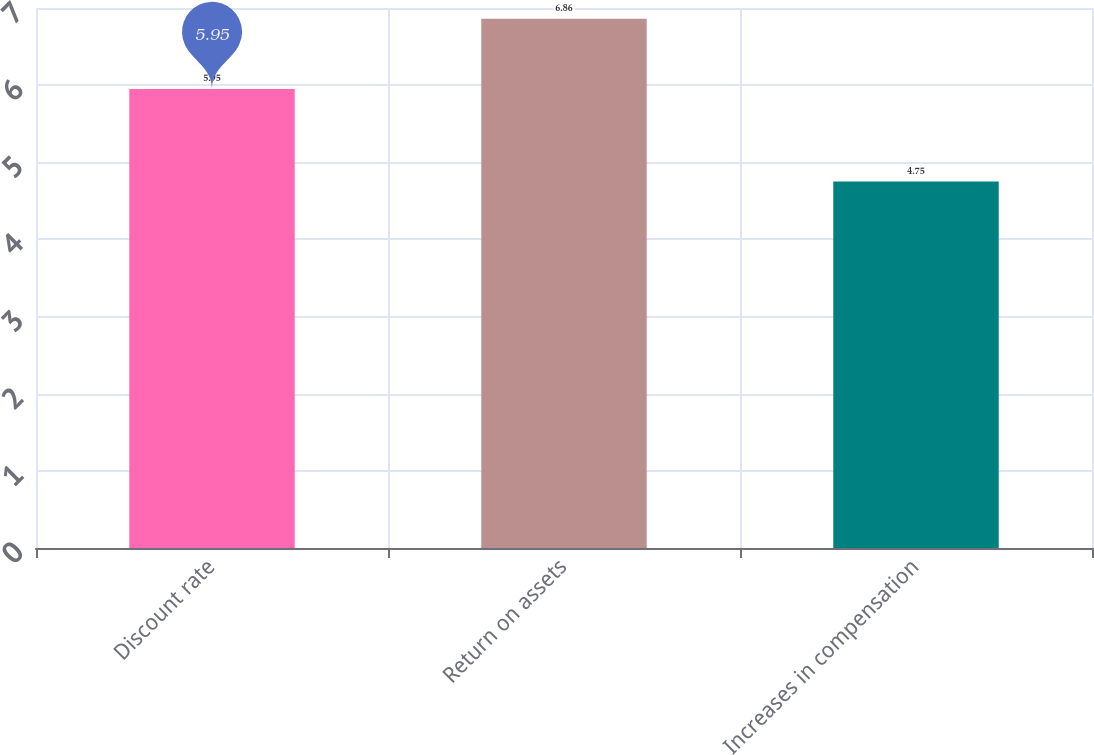Convert chart to OTSL. <chart><loc_0><loc_0><loc_500><loc_500><bar_chart><fcel>Discount rate<fcel>Return on assets<fcel>Increases in compensation<nl><fcel>5.95<fcel>6.86<fcel>4.75<nl></chart> 